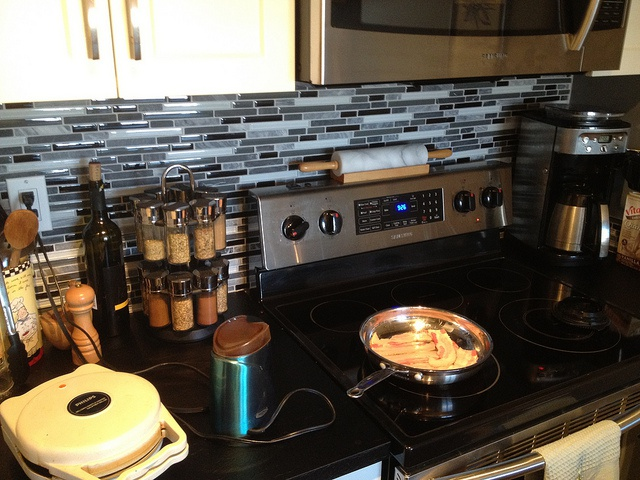Describe the objects in this image and their specific colors. I can see oven in ivory, black, gray, and maroon tones, microwave in ivory, black, and gray tones, oven in ivory, black, tan, and maroon tones, bottle in ivory, black, gray, and maroon tones, and bottle in ivory, black, maroon, and gray tones in this image. 